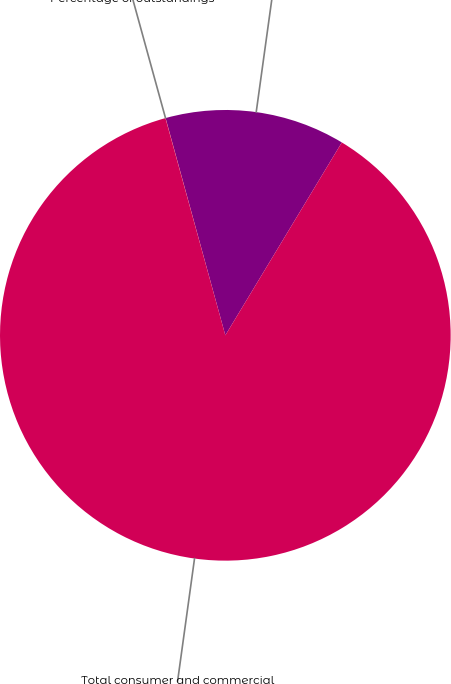Convert chart to OTSL. <chart><loc_0><loc_0><loc_500><loc_500><pie_chart><fcel>Total consumer loans and<fcel>Total consumer and commercial<fcel>Percentage of outstandings<nl><fcel>12.92%<fcel>87.07%<fcel>0.01%<nl></chart> 